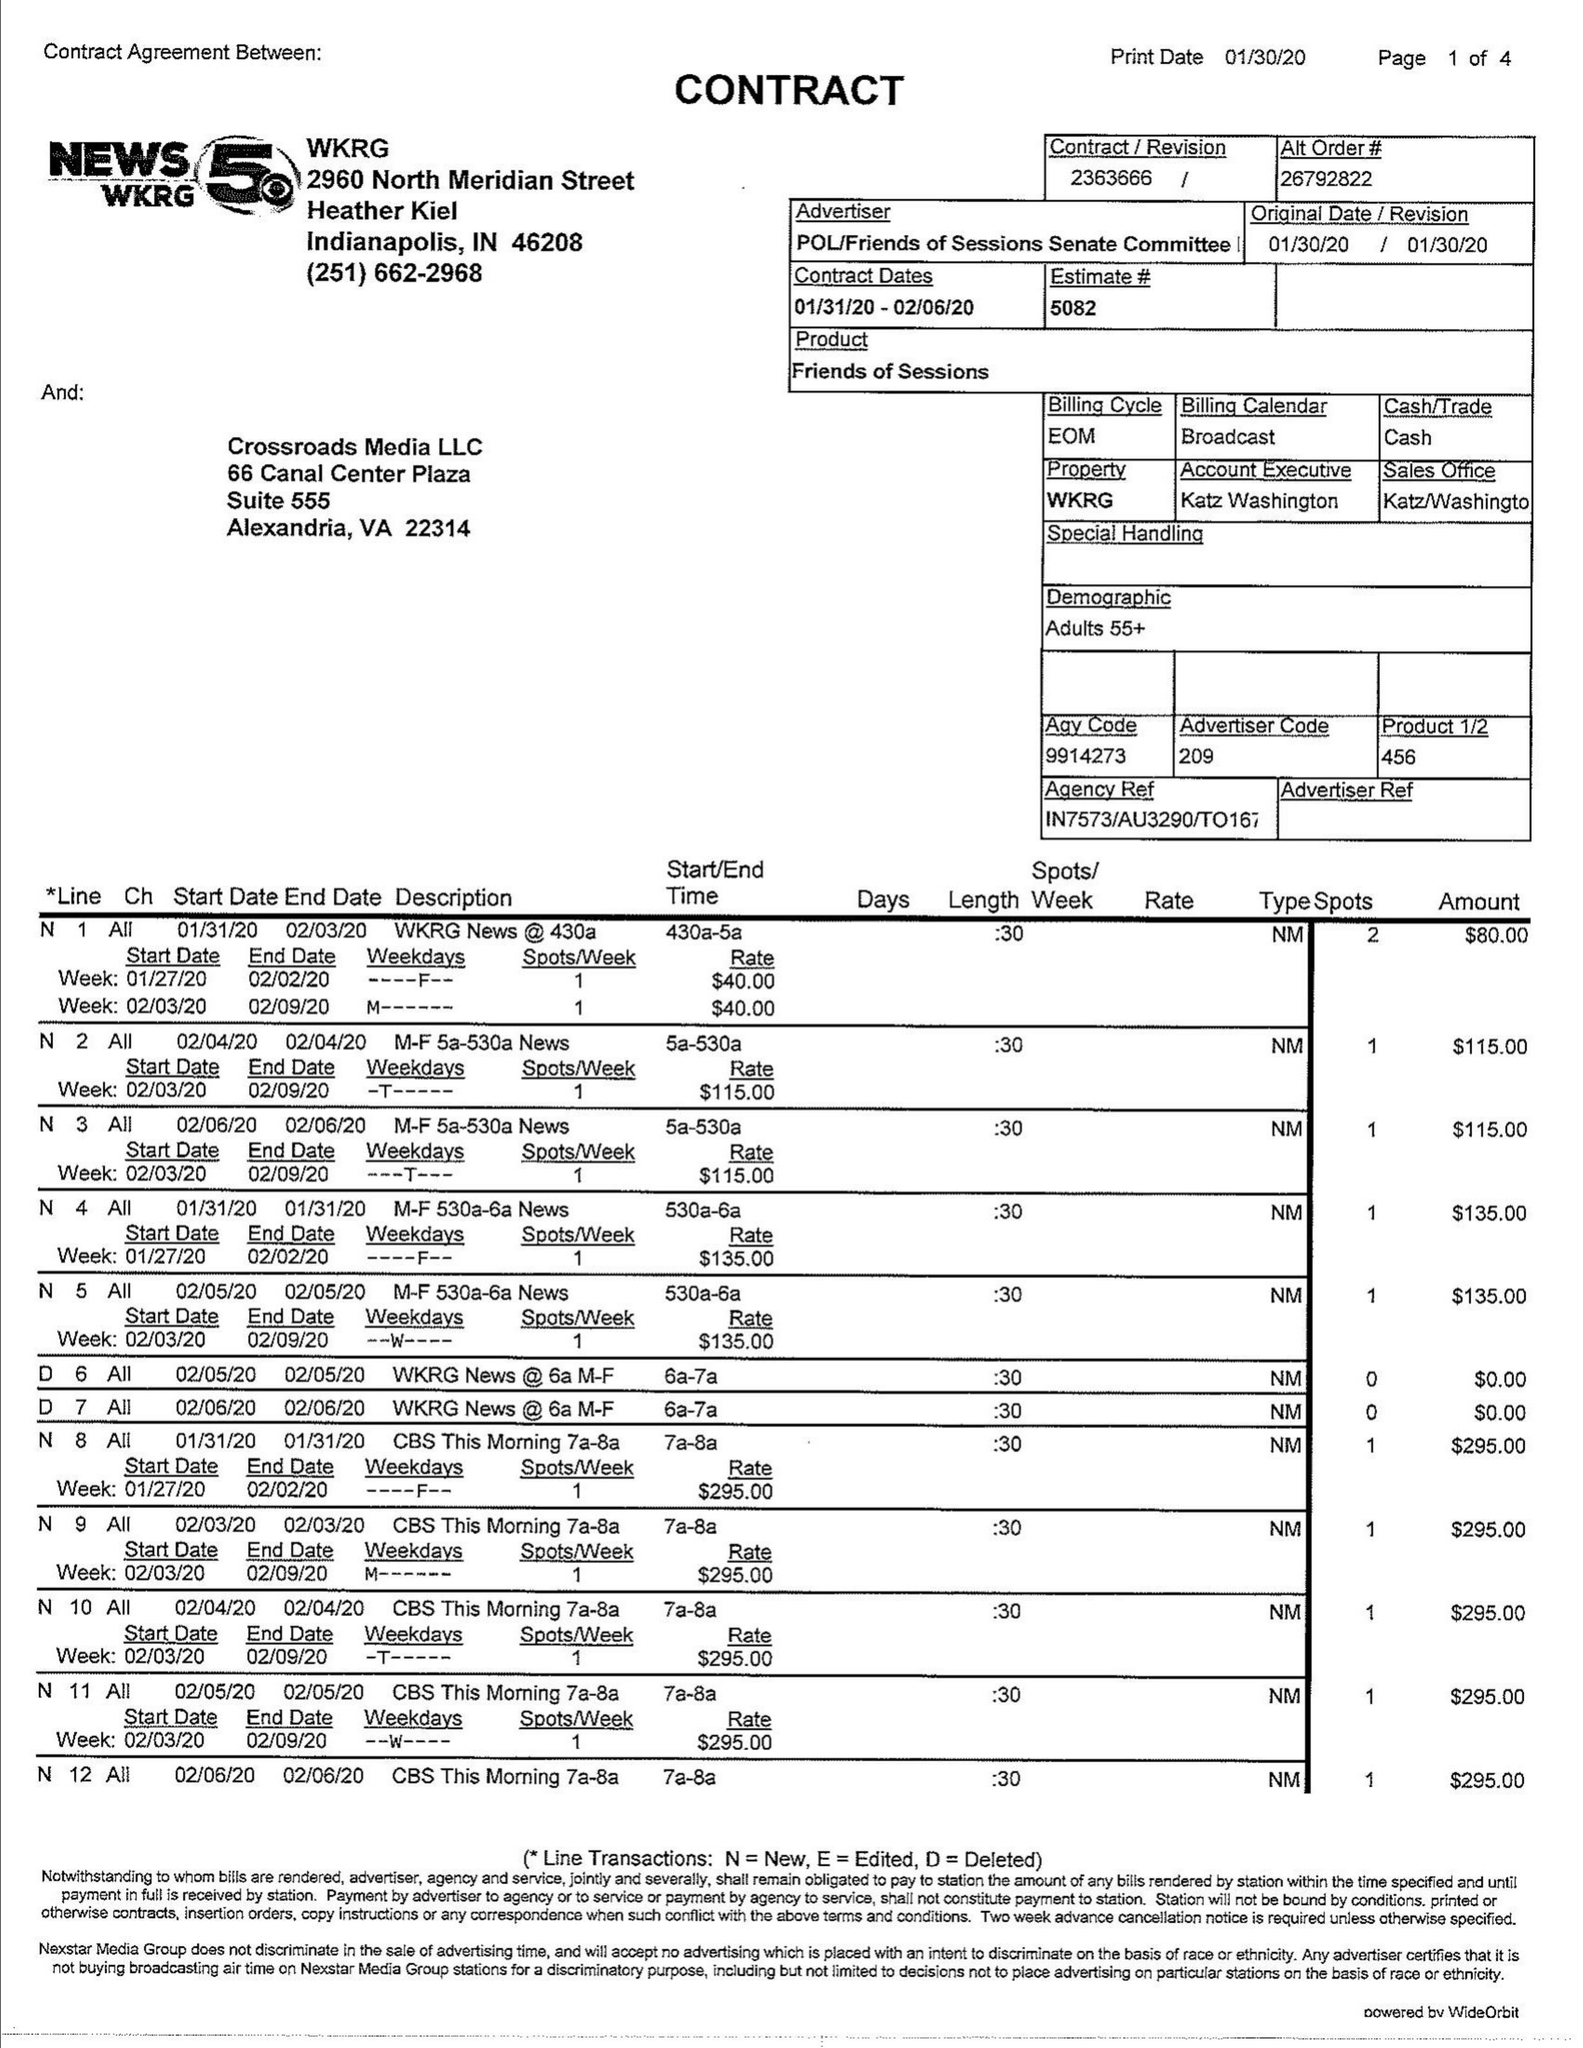What is the value for the gross_amount?
Answer the question using a single word or phrase. 18215.00 